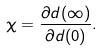Convert formula to latex. <formula><loc_0><loc_0><loc_500><loc_500>\chi = \frac { \partial d ( \infty ) } { \partial d ( 0 ) } .</formula> 